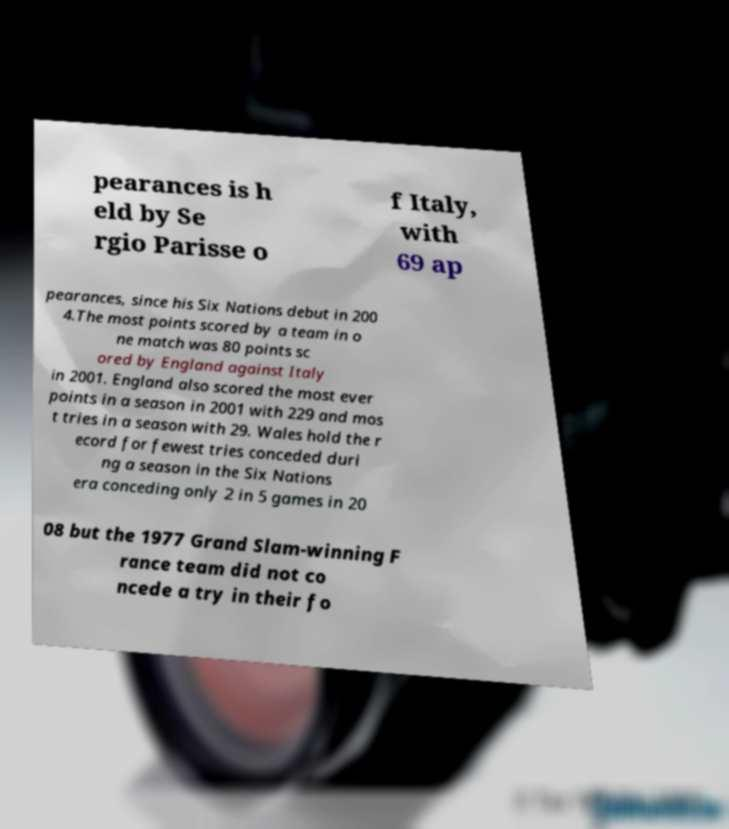There's text embedded in this image that I need extracted. Can you transcribe it verbatim? pearances is h eld by Se rgio Parisse o f Italy, with 69 ap pearances, since his Six Nations debut in 200 4.The most points scored by a team in o ne match was 80 points sc ored by England against Italy in 2001. England also scored the most ever points in a season in 2001 with 229 and mos t tries in a season with 29. Wales hold the r ecord for fewest tries conceded duri ng a season in the Six Nations era conceding only 2 in 5 games in 20 08 but the 1977 Grand Slam-winning F rance team did not co ncede a try in their fo 